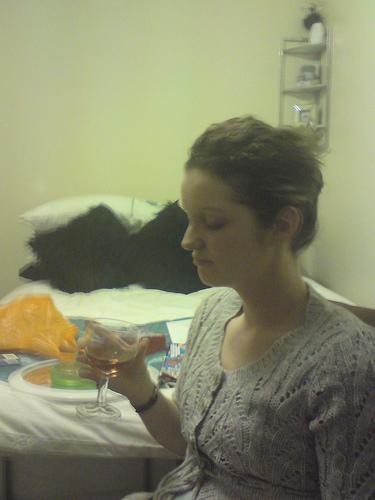How many people are in the room?
Give a very brief answer. 1. 